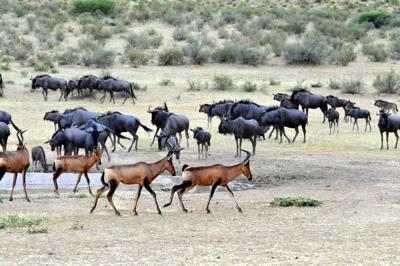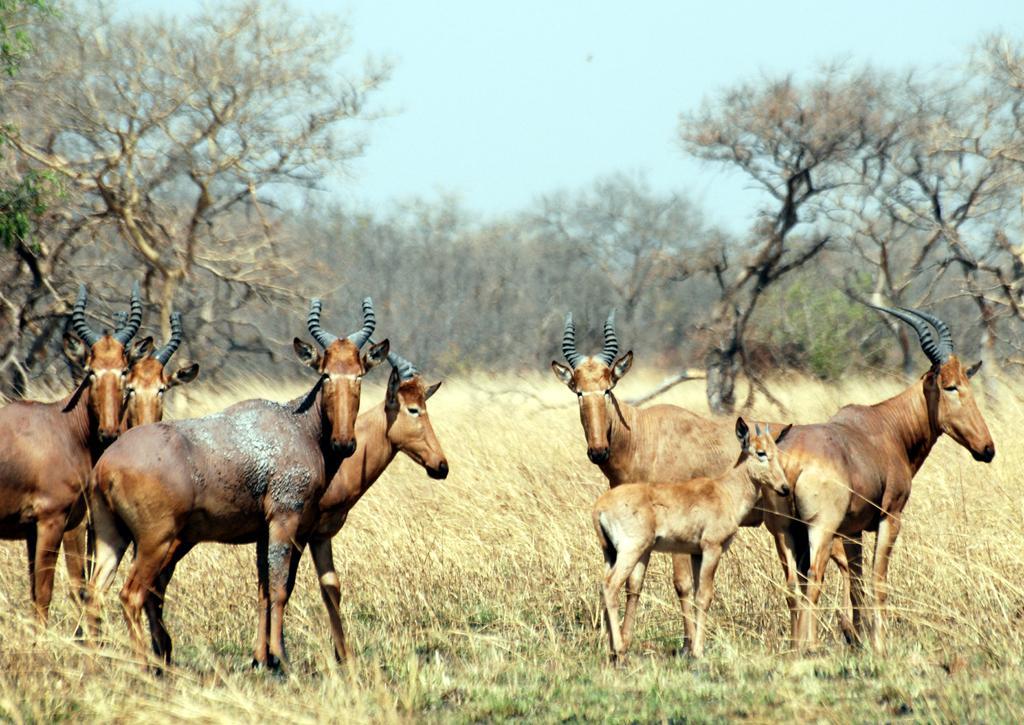The first image is the image on the left, the second image is the image on the right. For the images displayed, is the sentence "The left image shows brown antelope with another type of hooved mammal." factually correct? Answer yes or no. Yes. 